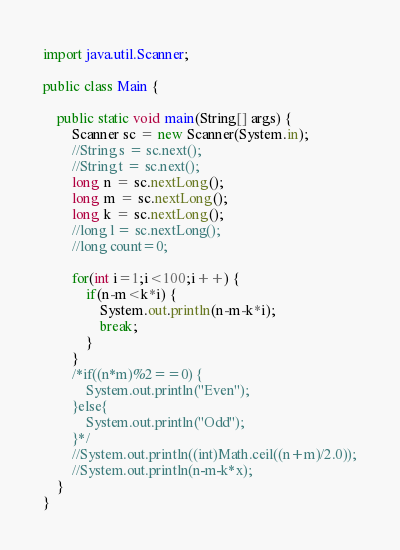<code> <loc_0><loc_0><loc_500><loc_500><_Java_>import java.util.Scanner;

public class Main {

	public static void main(String[] args) {
		Scanner sc = new Scanner(System.in);
		//String s = sc.next();
		//String t = sc.next();
		long n = sc.nextLong();
		long m = sc.nextLong();
		long k = sc.nextLong();
		//long l = sc.nextLong();
		//long count=0;

		for(int i=1;i<100;i++) {
			if(n-m<k*i) {
				System.out.println(n-m-k*i);
				break;
			}
		}
		/*if((n*m)%2==0) {
			System.out.println("Even");
		}else{
			System.out.println("Odd");
		}*/
		//System.out.println((int)Math.ceil((n+m)/2.0));
		//System.out.println(n-m-k*x);
	}
}


</code> 